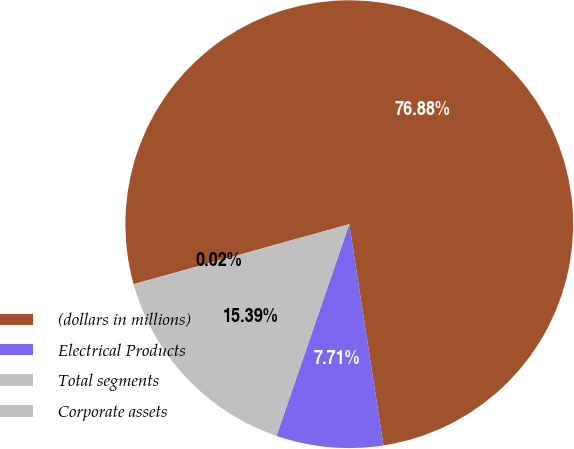<chart> <loc_0><loc_0><loc_500><loc_500><pie_chart><fcel>(dollars in millions)<fcel>Electrical Products<fcel>Total segments<fcel>Corporate assets<nl><fcel>76.88%<fcel>7.71%<fcel>15.39%<fcel>0.02%<nl></chart> 